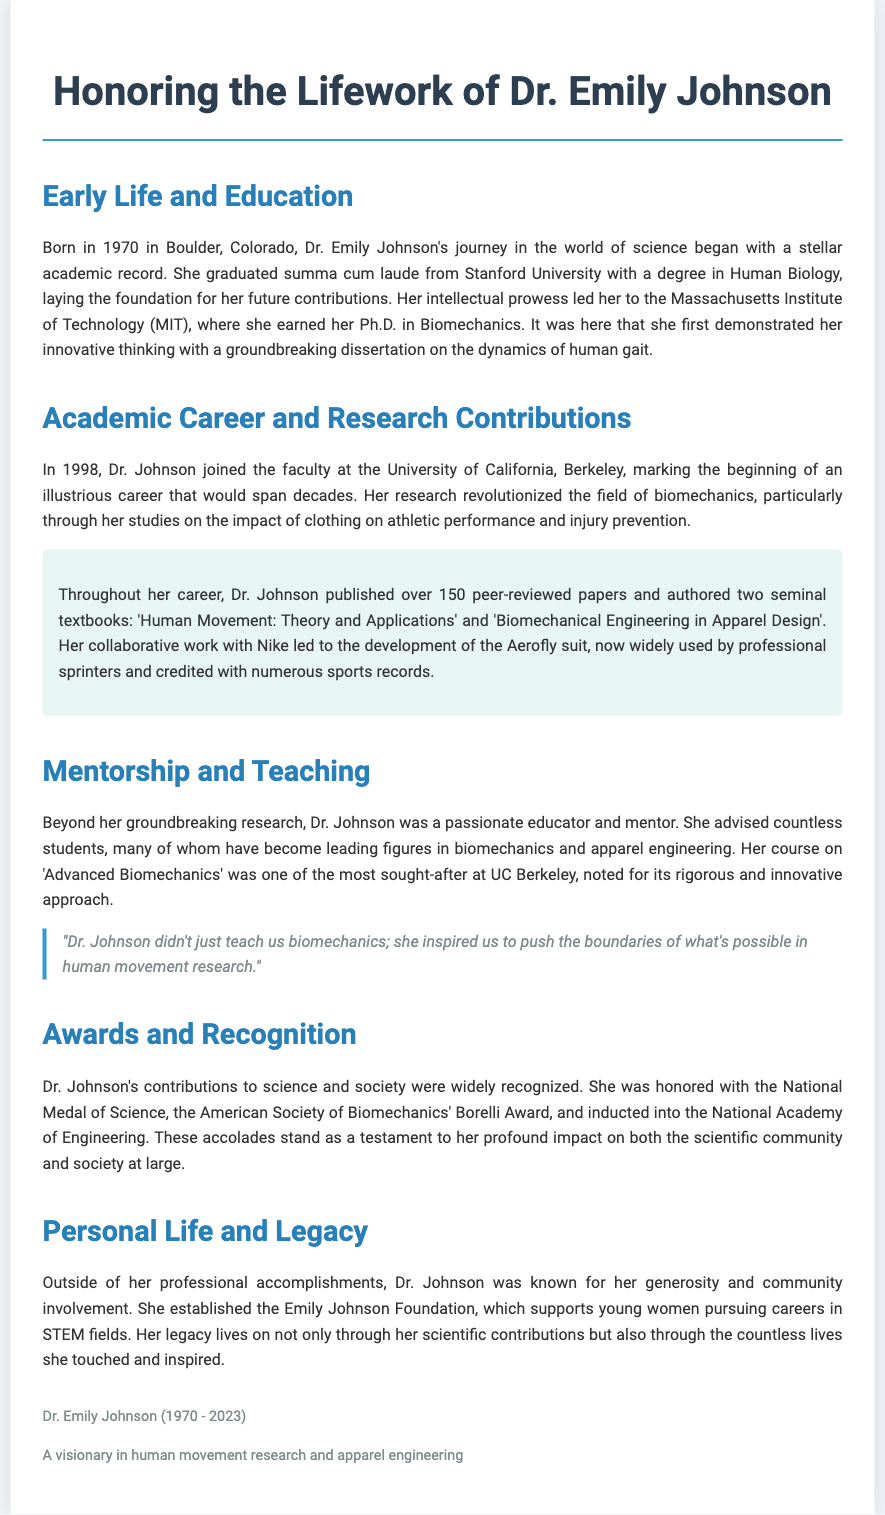What year was Dr. Emily Johnson born? The document states that Dr. Emily Johnson was born in 1970.
Answer: 1970 How many peer-reviewed papers did Dr. Johnson publish? According to the document, Dr. Johnson published over 150 peer-reviewed papers.
Answer: 150 Which university did Dr. Johnson attend for her Ph.D.? The document mentions that Dr. Johnson earned her Ph.D. at the Massachusetts Institute of Technology (MIT).
Answer: MIT What is the title of one of Dr. Johnson's textbooks? The document lists two textbooks authored by Dr. Johnson; one of them is titled 'Human Movement: Theory and Applications'.
Answer: 'Human Movement: Theory and Applications' What award did Dr. Johnson receive that is related to science? The document states that she was honored with the National Medal of Science.
Answer: National Medal of Science Why is Dr. Johnson's Aerofly suit significant? The document explains that the Aerofly suit is credited with numerous sports records.
Answer: Sports records What type of course was considered one of the most sought-after at UC Berkeley? The document notes that Dr. Johnson's course on 'Advanced Biomechanics' was highly sought after.
Answer: 'Advanced Biomechanics' What foundation did Dr. Johnson establish? The document indicates that she established the Emily Johnson Foundation.
Answer: Emily Johnson Foundation 